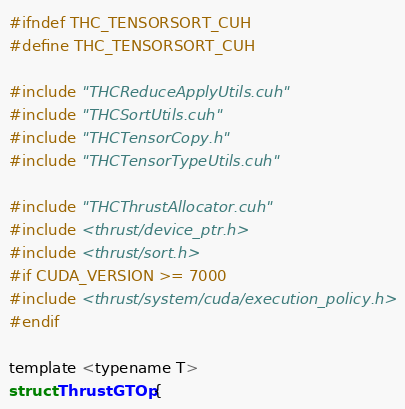Convert code to text. <code><loc_0><loc_0><loc_500><loc_500><_Cuda_>#ifndef THC_TENSORSORT_CUH
#define THC_TENSORSORT_CUH

#include "THCReduceApplyUtils.cuh"
#include "THCSortUtils.cuh"
#include "THCTensorCopy.h"
#include "THCTensorTypeUtils.cuh"

#include "THCThrustAllocator.cuh"
#include <thrust/device_ptr.h>
#include <thrust/sort.h>
#if CUDA_VERSION >= 7000
#include <thrust/system/cuda/execution_policy.h>
#endif

template <typename T>
struct ThrustGTOp {</code> 